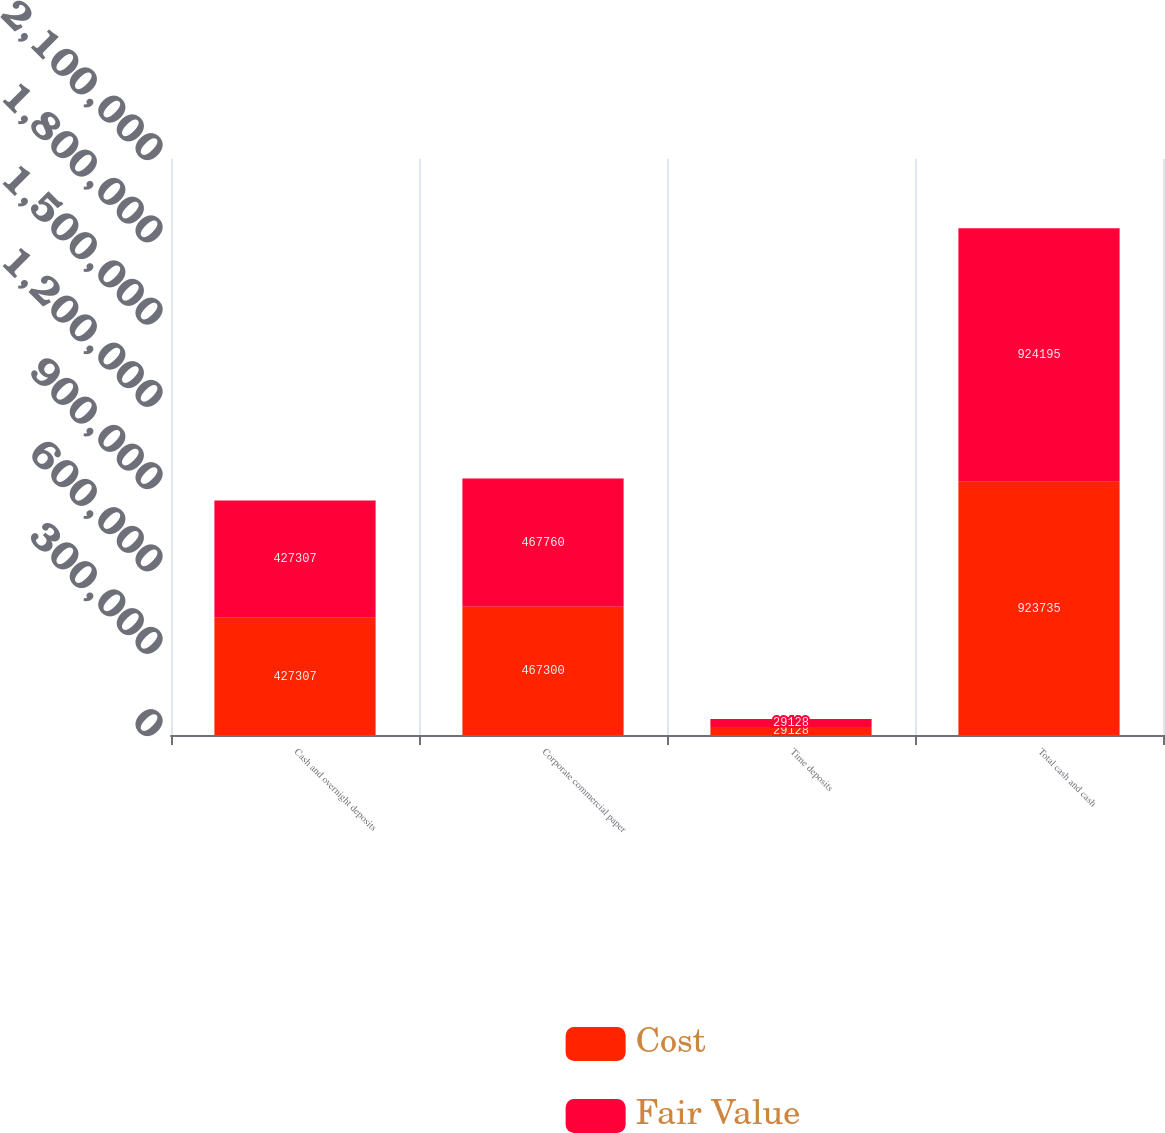Convert chart. <chart><loc_0><loc_0><loc_500><loc_500><stacked_bar_chart><ecel><fcel>Cash and overnight deposits<fcel>Corporate commercial paper<fcel>Time deposits<fcel>Total cash and cash<nl><fcel>Cost<fcel>427307<fcel>467300<fcel>29128<fcel>923735<nl><fcel>Fair Value<fcel>427307<fcel>467760<fcel>29128<fcel>924195<nl></chart> 